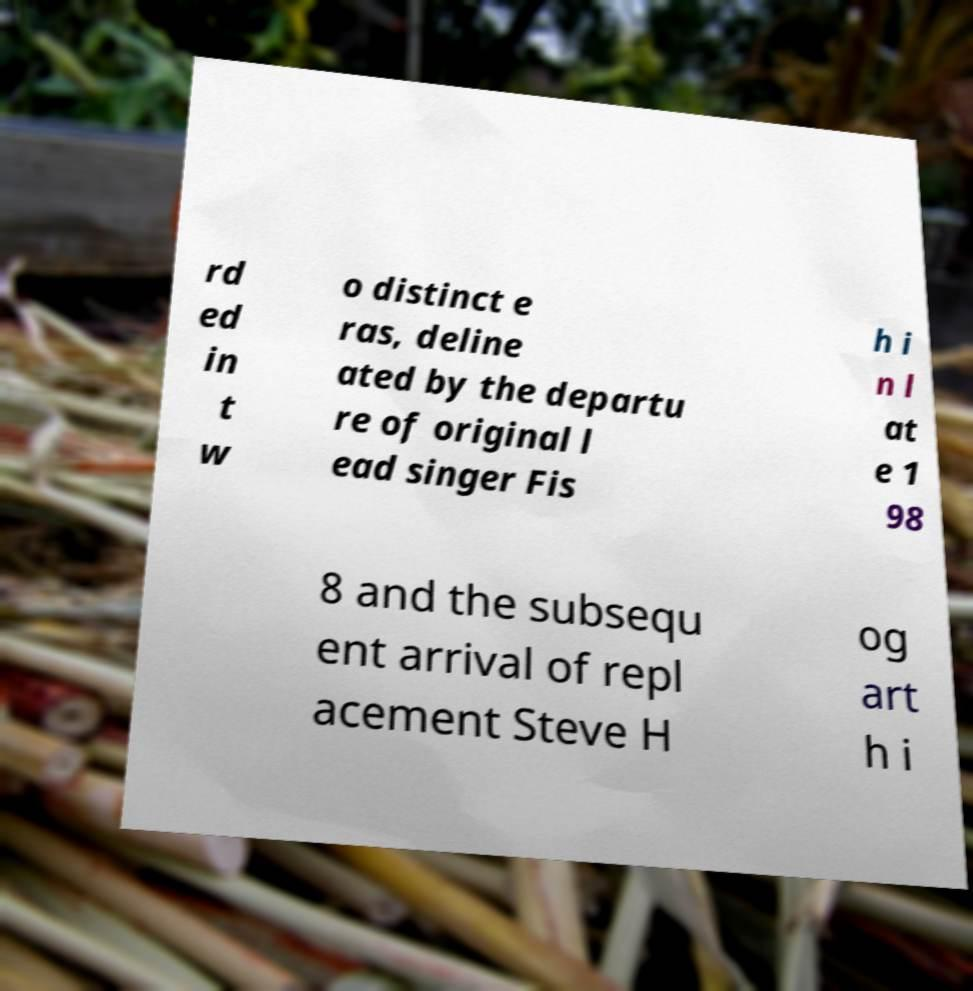Please read and relay the text visible in this image. What does it say? rd ed in t w o distinct e ras, deline ated by the departu re of original l ead singer Fis h i n l at e 1 98 8 and the subsequ ent arrival of repl acement Steve H og art h i 